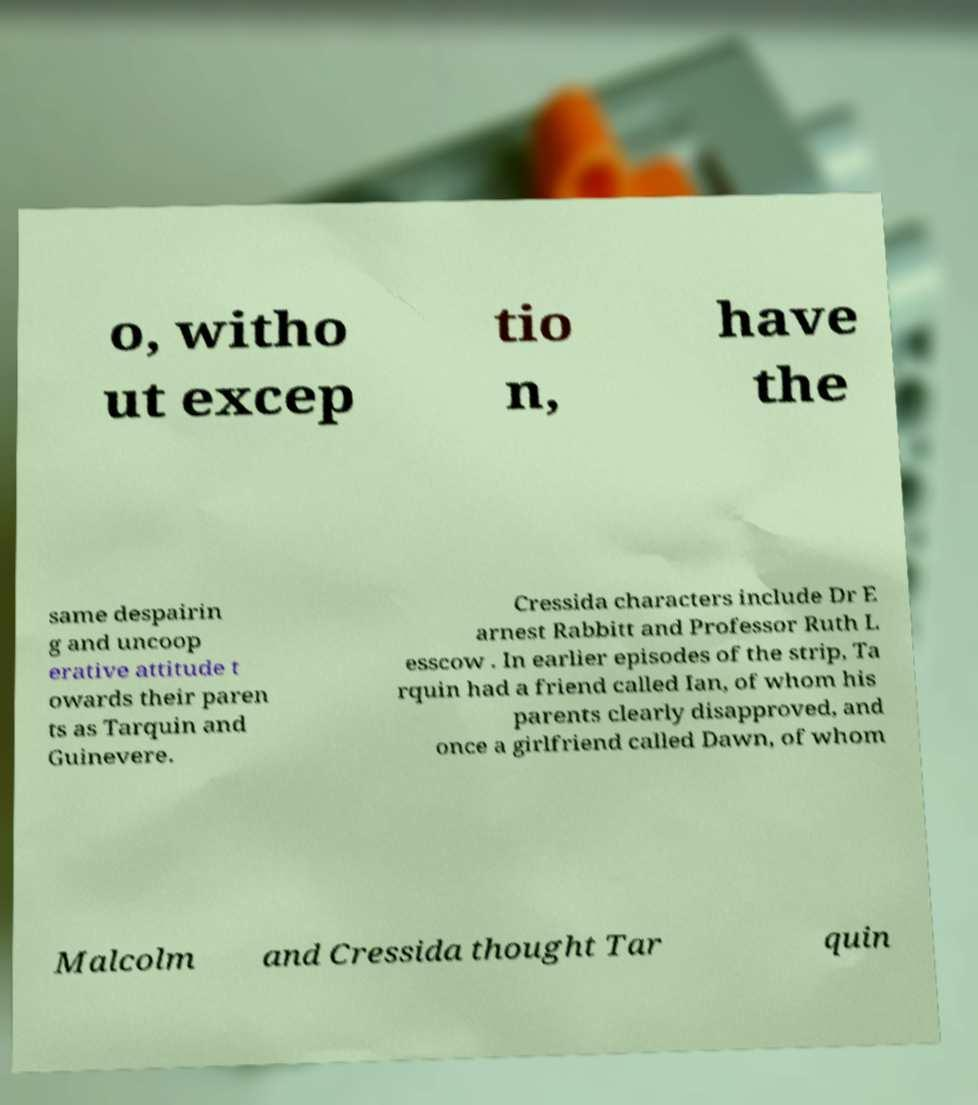Can you accurately transcribe the text from the provided image for me? o, witho ut excep tio n, have the same despairin g and uncoop erative attitude t owards their paren ts as Tarquin and Guinevere. Cressida characters include Dr E arnest Rabbitt and Professor Ruth L esscow . In earlier episodes of the strip, Ta rquin had a friend called Ian, of whom his parents clearly disapproved, and once a girlfriend called Dawn, of whom Malcolm and Cressida thought Tar quin 